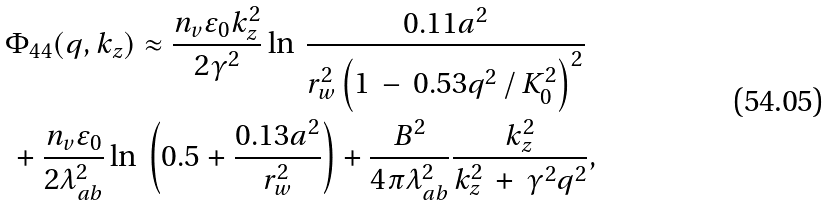Convert formula to latex. <formula><loc_0><loc_0><loc_500><loc_500>& \Phi _ { 4 4 } ( q , k _ { z } ) \approx \frac { n _ { v } \varepsilon _ { 0 } k _ { z } ^ { 2 } } { 2 \gamma ^ { 2 } } \ln \, \frac { 0 . 1 1 a ^ { 2 } } { r _ { w } ^ { 2 } \left ( 1 \, - \, 0 . 5 3 q ^ { 2 } \, / \, K _ { 0 } ^ { 2 } \right ) ^ { 2 } } \\ & \, + \frac { n _ { v } \varepsilon _ { 0 } } { 2 \lambda _ { a b } ^ { 2 } } \ln \, \left ( 0 . 5 + \frac { 0 . 1 3 a ^ { 2 } } { r _ { w } ^ { 2 } } \right ) + \frac { B ^ { 2 } } { 4 \pi \lambda _ { a b } ^ { 2 } } \frac { k _ { z } ^ { 2 } } { k _ { z } ^ { 2 } \, + \, \gamma ^ { 2 } q ^ { 2 } } ,</formula> 